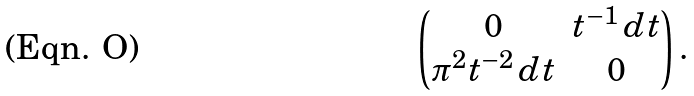Convert formula to latex. <formula><loc_0><loc_0><loc_500><loc_500>\begin{pmatrix} 0 & t ^ { - 1 } \, d t \\ \pi ^ { 2 } t ^ { - 2 } \, d t & 0 \end{pmatrix} .</formula> 